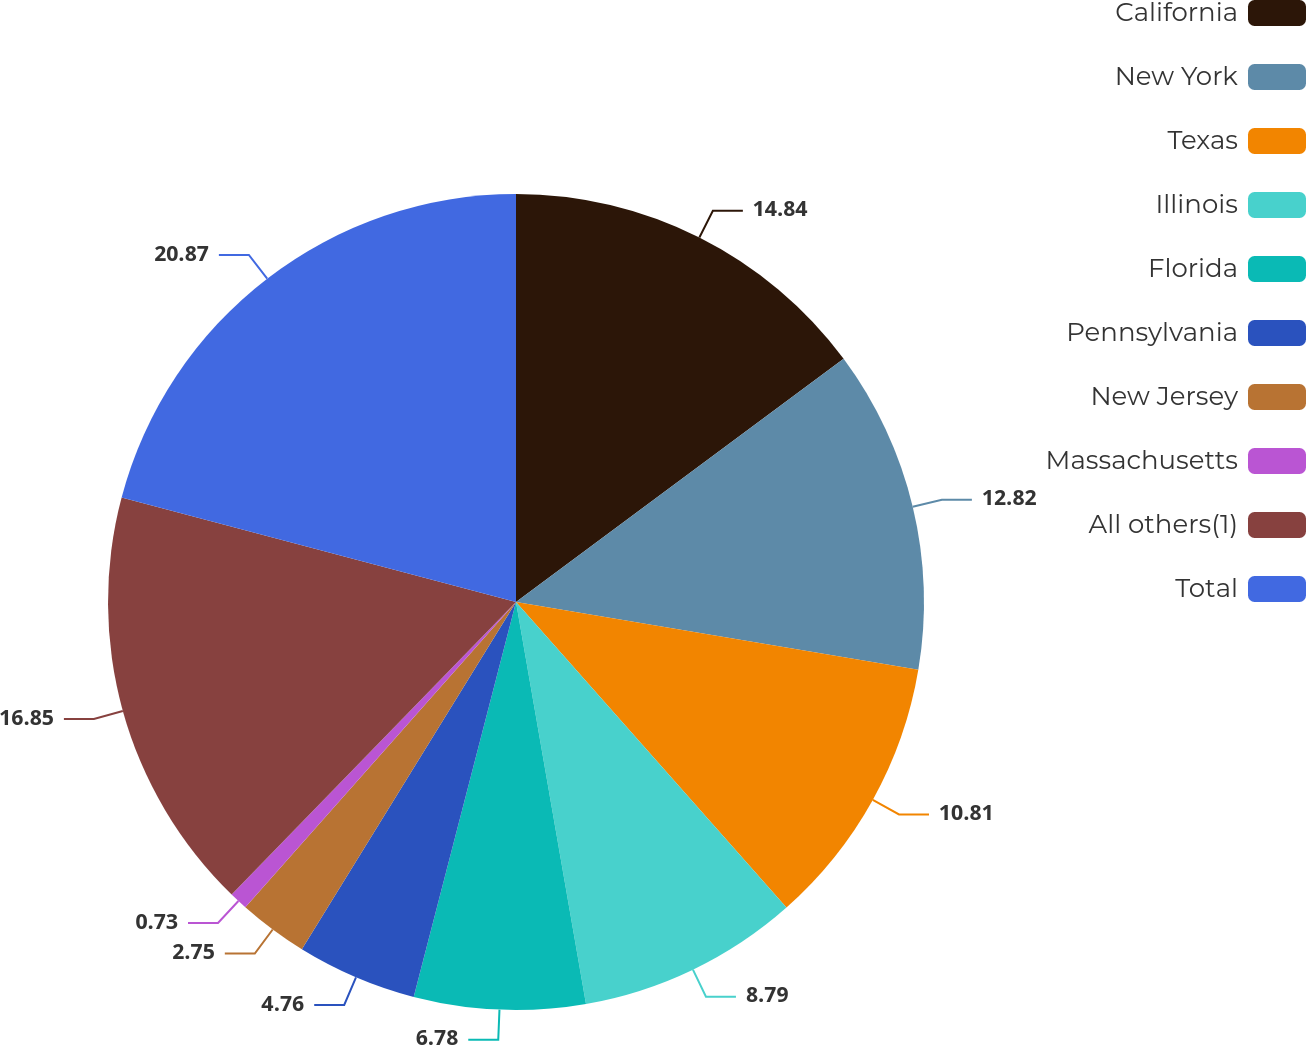Convert chart. <chart><loc_0><loc_0><loc_500><loc_500><pie_chart><fcel>California<fcel>New York<fcel>Texas<fcel>Illinois<fcel>Florida<fcel>Pennsylvania<fcel>New Jersey<fcel>Massachusetts<fcel>All others(1)<fcel>Total<nl><fcel>14.84%<fcel>12.82%<fcel>10.81%<fcel>8.79%<fcel>6.78%<fcel>4.76%<fcel>2.75%<fcel>0.73%<fcel>16.85%<fcel>20.88%<nl></chart> 